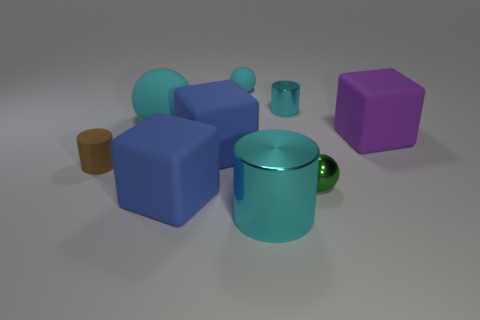Does the metal cylinder that is in front of the purple rubber thing have the same size as the big purple block?
Make the answer very short. Yes. There is a cyan cylinder that is behind the tiny brown object; how big is it?
Your response must be concise. Small. Are there any other things that are the same material as the purple object?
Provide a succinct answer. Yes. How many large blue blocks are there?
Provide a short and direct response. 2. Does the large matte sphere have the same color as the large metallic thing?
Make the answer very short. Yes. There is a tiny object that is in front of the small cyan cylinder and right of the big rubber sphere; what is its color?
Offer a terse response. Green. There is a purple thing; are there any tiny things behind it?
Offer a very short reply. Yes. How many big matte objects are on the left side of the cylinder right of the large cylinder?
Your response must be concise. 3. There is a brown thing that is the same material as the large purple cube; what size is it?
Offer a very short reply. Small. What is the size of the matte cylinder?
Ensure brevity in your answer.  Small. 